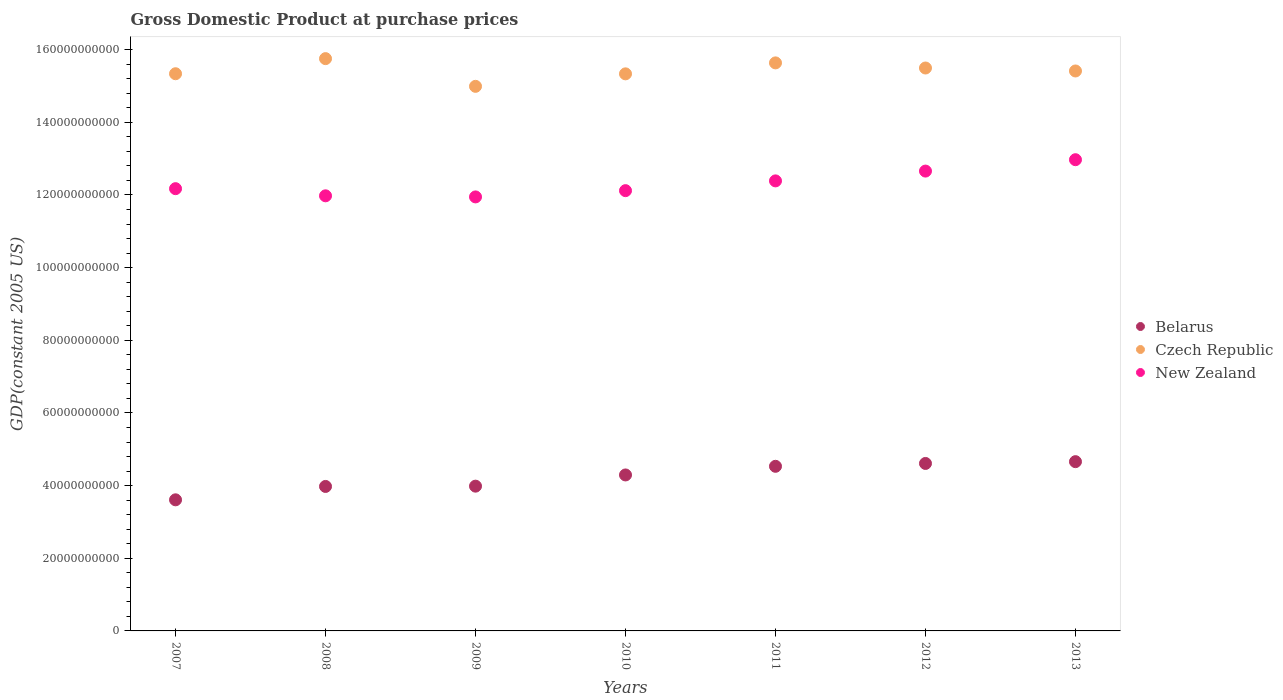Is the number of dotlines equal to the number of legend labels?
Provide a succinct answer. Yes. What is the GDP at purchase prices in Belarus in 2011?
Your answer should be compact. 4.53e+1. Across all years, what is the maximum GDP at purchase prices in Czech Republic?
Give a very brief answer. 1.58e+11. Across all years, what is the minimum GDP at purchase prices in New Zealand?
Your response must be concise. 1.19e+11. In which year was the GDP at purchase prices in Czech Republic maximum?
Give a very brief answer. 2008. What is the total GDP at purchase prices in Belarus in the graph?
Your answer should be very brief. 2.97e+11. What is the difference between the GDP at purchase prices in New Zealand in 2009 and that in 2013?
Offer a very short reply. -1.02e+1. What is the difference between the GDP at purchase prices in New Zealand in 2008 and the GDP at purchase prices in Czech Republic in 2010?
Keep it short and to the point. -3.36e+1. What is the average GDP at purchase prices in New Zealand per year?
Provide a succinct answer. 1.23e+11. In the year 2007, what is the difference between the GDP at purchase prices in Belarus and GDP at purchase prices in New Zealand?
Your answer should be very brief. -8.57e+1. In how many years, is the GDP at purchase prices in New Zealand greater than 128000000000 US$?
Ensure brevity in your answer.  1. What is the ratio of the GDP at purchase prices in Belarus in 2008 to that in 2012?
Keep it short and to the point. 0.86. Is the difference between the GDP at purchase prices in Belarus in 2008 and 2010 greater than the difference between the GDP at purchase prices in New Zealand in 2008 and 2010?
Give a very brief answer. No. What is the difference between the highest and the second highest GDP at purchase prices in Czech Republic?
Give a very brief answer. 1.17e+09. What is the difference between the highest and the lowest GDP at purchase prices in New Zealand?
Keep it short and to the point. 1.02e+1. Is it the case that in every year, the sum of the GDP at purchase prices in Czech Republic and GDP at purchase prices in Belarus  is greater than the GDP at purchase prices in New Zealand?
Provide a short and direct response. Yes. Is the GDP at purchase prices in Czech Republic strictly less than the GDP at purchase prices in New Zealand over the years?
Keep it short and to the point. No. How many years are there in the graph?
Your answer should be very brief. 7. Are the values on the major ticks of Y-axis written in scientific E-notation?
Provide a short and direct response. No. Does the graph contain any zero values?
Offer a very short reply. No. Where does the legend appear in the graph?
Provide a short and direct response. Center right. How are the legend labels stacked?
Make the answer very short. Vertical. What is the title of the graph?
Provide a succinct answer. Gross Domestic Product at purchase prices. Does "Lower middle income" appear as one of the legend labels in the graph?
Offer a very short reply. No. What is the label or title of the X-axis?
Provide a short and direct response. Years. What is the label or title of the Y-axis?
Offer a very short reply. GDP(constant 2005 US). What is the GDP(constant 2005 US) of Belarus in 2007?
Provide a succinct answer. 3.61e+1. What is the GDP(constant 2005 US) in Czech Republic in 2007?
Give a very brief answer. 1.53e+11. What is the GDP(constant 2005 US) in New Zealand in 2007?
Your answer should be very brief. 1.22e+11. What is the GDP(constant 2005 US) in Belarus in 2008?
Make the answer very short. 3.98e+1. What is the GDP(constant 2005 US) in Czech Republic in 2008?
Provide a succinct answer. 1.58e+11. What is the GDP(constant 2005 US) of New Zealand in 2008?
Your answer should be very brief. 1.20e+11. What is the GDP(constant 2005 US) of Belarus in 2009?
Keep it short and to the point. 3.98e+1. What is the GDP(constant 2005 US) of Czech Republic in 2009?
Provide a short and direct response. 1.50e+11. What is the GDP(constant 2005 US) of New Zealand in 2009?
Your answer should be compact. 1.19e+11. What is the GDP(constant 2005 US) in Belarus in 2010?
Give a very brief answer. 4.29e+1. What is the GDP(constant 2005 US) in Czech Republic in 2010?
Your answer should be very brief. 1.53e+11. What is the GDP(constant 2005 US) of New Zealand in 2010?
Provide a succinct answer. 1.21e+11. What is the GDP(constant 2005 US) in Belarus in 2011?
Your answer should be compact. 4.53e+1. What is the GDP(constant 2005 US) in Czech Republic in 2011?
Your answer should be very brief. 1.56e+11. What is the GDP(constant 2005 US) in New Zealand in 2011?
Your response must be concise. 1.24e+11. What is the GDP(constant 2005 US) in Belarus in 2012?
Provide a succinct answer. 4.61e+1. What is the GDP(constant 2005 US) of Czech Republic in 2012?
Provide a succinct answer. 1.55e+11. What is the GDP(constant 2005 US) in New Zealand in 2012?
Your answer should be very brief. 1.27e+11. What is the GDP(constant 2005 US) in Belarus in 2013?
Make the answer very short. 4.66e+1. What is the GDP(constant 2005 US) of Czech Republic in 2013?
Offer a terse response. 1.54e+11. What is the GDP(constant 2005 US) in New Zealand in 2013?
Offer a terse response. 1.30e+11. Across all years, what is the maximum GDP(constant 2005 US) in Belarus?
Provide a short and direct response. 4.66e+1. Across all years, what is the maximum GDP(constant 2005 US) in Czech Republic?
Provide a succinct answer. 1.58e+11. Across all years, what is the maximum GDP(constant 2005 US) of New Zealand?
Your answer should be compact. 1.30e+11. Across all years, what is the minimum GDP(constant 2005 US) in Belarus?
Your answer should be compact. 3.61e+1. Across all years, what is the minimum GDP(constant 2005 US) of Czech Republic?
Give a very brief answer. 1.50e+11. Across all years, what is the minimum GDP(constant 2005 US) of New Zealand?
Give a very brief answer. 1.19e+11. What is the total GDP(constant 2005 US) of Belarus in the graph?
Your answer should be very brief. 2.97e+11. What is the total GDP(constant 2005 US) in Czech Republic in the graph?
Keep it short and to the point. 1.08e+12. What is the total GDP(constant 2005 US) in New Zealand in the graph?
Offer a very short reply. 8.62e+11. What is the difference between the GDP(constant 2005 US) in Belarus in 2007 and that in 2008?
Give a very brief answer. -3.68e+09. What is the difference between the GDP(constant 2005 US) in Czech Republic in 2007 and that in 2008?
Offer a very short reply. -4.16e+09. What is the difference between the GDP(constant 2005 US) in New Zealand in 2007 and that in 2008?
Give a very brief answer. 1.97e+09. What is the difference between the GDP(constant 2005 US) in Belarus in 2007 and that in 2009?
Your answer should be compact. -3.76e+09. What is the difference between the GDP(constant 2005 US) of Czech Republic in 2007 and that in 2009?
Provide a short and direct response. 3.47e+09. What is the difference between the GDP(constant 2005 US) in New Zealand in 2007 and that in 2009?
Your answer should be very brief. 2.27e+09. What is the difference between the GDP(constant 2005 US) of Belarus in 2007 and that in 2010?
Make the answer very short. -6.85e+09. What is the difference between the GDP(constant 2005 US) in Czech Republic in 2007 and that in 2010?
Make the answer very short. 2.90e+07. What is the difference between the GDP(constant 2005 US) in New Zealand in 2007 and that in 2010?
Your answer should be very brief. 5.45e+08. What is the difference between the GDP(constant 2005 US) in Belarus in 2007 and that in 2011?
Provide a short and direct response. -9.23e+09. What is the difference between the GDP(constant 2005 US) in Czech Republic in 2007 and that in 2011?
Your response must be concise. -2.99e+09. What is the difference between the GDP(constant 2005 US) in New Zealand in 2007 and that in 2011?
Offer a very short reply. -2.14e+09. What is the difference between the GDP(constant 2005 US) in Belarus in 2007 and that in 2012?
Offer a terse response. -1.00e+1. What is the difference between the GDP(constant 2005 US) of Czech Republic in 2007 and that in 2012?
Your answer should be very brief. -1.58e+09. What is the difference between the GDP(constant 2005 US) of New Zealand in 2007 and that in 2012?
Provide a succinct answer. -4.84e+09. What is the difference between the GDP(constant 2005 US) in Belarus in 2007 and that in 2013?
Ensure brevity in your answer.  -1.05e+1. What is the difference between the GDP(constant 2005 US) in Czech Republic in 2007 and that in 2013?
Provide a succinct answer. -7.61e+08. What is the difference between the GDP(constant 2005 US) of New Zealand in 2007 and that in 2013?
Your answer should be very brief. -7.97e+09. What is the difference between the GDP(constant 2005 US) of Belarus in 2008 and that in 2009?
Offer a terse response. -7.95e+07. What is the difference between the GDP(constant 2005 US) in Czech Republic in 2008 and that in 2009?
Give a very brief answer. 7.63e+09. What is the difference between the GDP(constant 2005 US) in New Zealand in 2008 and that in 2009?
Ensure brevity in your answer.  3.01e+08. What is the difference between the GDP(constant 2005 US) in Belarus in 2008 and that in 2010?
Keep it short and to the point. -3.16e+09. What is the difference between the GDP(constant 2005 US) in Czech Republic in 2008 and that in 2010?
Provide a short and direct response. 4.19e+09. What is the difference between the GDP(constant 2005 US) of New Zealand in 2008 and that in 2010?
Offer a terse response. -1.42e+09. What is the difference between the GDP(constant 2005 US) of Belarus in 2008 and that in 2011?
Keep it short and to the point. -5.54e+09. What is the difference between the GDP(constant 2005 US) in Czech Republic in 2008 and that in 2011?
Your answer should be compact. 1.17e+09. What is the difference between the GDP(constant 2005 US) in New Zealand in 2008 and that in 2011?
Give a very brief answer. -4.11e+09. What is the difference between the GDP(constant 2005 US) in Belarus in 2008 and that in 2012?
Make the answer very short. -6.33e+09. What is the difference between the GDP(constant 2005 US) of Czech Republic in 2008 and that in 2012?
Your answer should be compact. 2.58e+09. What is the difference between the GDP(constant 2005 US) in New Zealand in 2008 and that in 2012?
Make the answer very short. -6.81e+09. What is the difference between the GDP(constant 2005 US) of Belarus in 2008 and that in 2013?
Your response must be concise. -6.82e+09. What is the difference between the GDP(constant 2005 US) of Czech Republic in 2008 and that in 2013?
Make the answer very short. 3.40e+09. What is the difference between the GDP(constant 2005 US) in New Zealand in 2008 and that in 2013?
Provide a short and direct response. -9.94e+09. What is the difference between the GDP(constant 2005 US) of Belarus in 2009 and that in 2010?
Provide a short and direct response. -3.08e+09. What is the difference between the GDP(constant 2005 US) in Czech Republic in 2009 and that in 2010?
Provide a short and direct response. -3.44e+09. What is the difference between the GDP(constant 2005 US) of New Zealand in 2009 and that in 2010?
Offer a terse response. -1.72e+09. What is the difference between the GDP(constant 2005 US) in Belarus in 2009 and that in 2011?
Keep it short and to the point. -5.46e+09. What is the difference between the GDP(constant 2005 US) in Czech Republic in 2009 and that in 2011?
Offer a very short reply. -6.46e+09. What is the difference between the GDP(constant 2005 US) in New Zealand in 2009 and that in 2011?
Provide a succinct answer. -4.41e+09. What is the difference between the GDP(constant 2005 US) in Belarus in 2009 and that in 2012?
Offer a very short reply. -6.25e+09. What is the difference between the GDP(constant 2005 US) in Czech Republic in 2009 and that in 2012?
Your answer should be compact. -5.05e+09. What is the difference between the GDP(constant 2005 US) in New Zealand in 2009 and that in 2012?
Your answer should be very brief. -7.11e+09. What is the difference between the GDP(constant 2005 US) in Belarus in 2009 and that in 2013?
Your response must be concise. -6.74e+09. What is the difference between the GDP(constant 2005 US) in Czech Republic in 2009 and that in 2013?
Provide a short and direct response. -4.23e+09. What is the difference between the GDP(constant 2005 US) of New Zealand in 2009 and that in 2013?
Provide a short and direct response. -1.02e+1. What is the difference between the GDP(constant 2005 US) of Belarus in 2010 and that in 2011?
Make the answer very short. -2.38e+09. What is the difference between the GDP(constant 2005 US) of Czech Republic in 2010 and that in 2011?
Keep it short and to the point. -3.02e+09. What is the difference between the GDP(constant 2005 US) in New Zealand in 2010 and that in 2011?
Ensure brevity in your answer.  -2.69e+09. What is the difference between the GDP(constant 2005 US) in Belarus in 2010 and that in 2012?
Ensure brevity in your answer.  -3.16e+09. What is the difference between the GDP(constant 2005 US) in Czech Republic in 2010 and that in 2012?
Make the answer very short. -1.61e+09. What is the difference between the GDP(constant 2005 US) in New Zealand in 2010 and that in 2012?
Provide a short and direct response. -5.39e+09. What is the difference between the GDP(constant 2005 US) of Belarus in 2010 and that in 2013?
Your answer should be very brief. -3.66e+09. What is the difference between the GDP(constant 2005 US) in Czech Republic in 2010 and that in 2013?
Make the answer very short. -7.90e+08. What is the difference between the GDP(constant 2005 US) of New Zealand in 2010 and that in 2013?
Provide a short and direct response. -8.52e+09. What is the difference between the GDP(constant 2005 US) in Belarus in 2011 and that in 2012?
Your answer should be very brief. -7.85e+08. What is the difference between the GDP(constant 2005 US) in Czech Republic in 2011 and that in 2012?
Provide a succinct answer. 1.41e+09. What is the difference between the GDP(constant 2005 US) in New Zealand in 2011 and that in 2012?
Keep it short and to the point. -2.70e+09. What is the difference between the GDP(constant 2005 US) of Belarus in 2011 and that in 2013?
Offer a very short reply. -1.28e+09. What is the difference between the GDP(constant 2005 US) of Czech Republic in 2011 and that in 2013?
Ensure brevity in your answer.  2.23e+09. What is the difference between the GDP(constant 2005 US) of New Zealand in 2011 and that in 2013?
Offer a terse response. -5.83e+09. What is the difference between the GDP(constant 2005 US) in Belarus in 2012 and that in 2013?
Offer a terse response. -4.95e+08. What is the difference between the GDP(constant 2005 US) in Czech Republic in 2012 and that in 2013?
Provide a short and direct response. 8.18e+08. What is the difference between the GDP(constant 2005 US) of New Zealand in 2012 and that in 2013?
Give a very brief answer. -3.13e+09. What is the difference between the GDP(constant 2005 US) in Belarus in 2007 and the GDP(constant 2005 US) in Czech Republic in 2008?
Your answer should be very brief. -1.21e+11. What is the difference between the GDP(constant 2005 US) of Belarus in 2007 and the GDP(constant 2005 US) of New Zealand in 2008?
Your answer should be compact. -8.37e+1. What is the difference between the GDP(constant 2005 US) of Czech Republic in 2007 and the GDP(constant 2005 US) of New Zealand in 2008?
Your answer should be compact. 3.36e+1. What is the difference between the GDP(constant 2005 US) in Belarus in 2007 and the GDP(constant 2005 US) in Czech Republic in 2009?
Keep it short and to the point. -1.14e+11. What is the difference between the GDP(constant 2005 US) in Belarus in 2007 and the GDP(constant 2005 US) in New Zealand in 2009?
Ensure brevity in your answer.  -8.34e+1. What is the difference between the GDP(constant 2005 US) in Czech Republic in 2007 and the GDP(constant 2005 US) in New Zealand in 2009?
Offer a very short reply. 3.39e+1. What is the difference between the GDP(constant 2005 US) of Belarus in 2007 and the GDP(constant 2005 US) of Czech Republic in 2010?
Provide a succinct answer. -1.17e+11. What is the difference between the GDP(constant 2005 US) of Belarus in 2007 and the GDP(constant 2005 US) of New Zealand in 2010?
Keep it short and to the point. -8.51e+1. What is the difference between the GDP(constant 2005 US) of Czech Republic in 2007 and the GDP(constant 2005 US) of New Zealand in 2010?
Ensure brevity in your answer.  3.22e+1. What is the difference between the GDP(constant 2005 US) in Belarus in 2007 and the GDP(constant 2005 US) in Czech Republic in 2011?
Make the answer very short. -1.20e+11. What is the difference between the GDP(constant 2005 US) of Belarus in 2007 and the GDP(constant 2005 US) of New Zealand in 2011?
Give a very brief answer. -8.78e+1. What is the difference between the GDP(constant 2005 US) in Czech Republic in 2007 and the GDP(constant 2005 US) in New Zealand in 2011?
Your answer should be compact. 2.95e+1. What is the difference between the GDP(constant 2005 US) of Belarus in 2007 and the GDP(constant 2005 US) of Czech Republic in 2012?
Offer a very short reply. -1.19e+11. What is the difference between the GDP(constant 2005 US) of Belarus in 2007 and the GDP(constant 2005 US) of New Zealand in 2012?
Keep it short and to the point. -9.05e+1. What is the difference between the GDP(constant 2005 US) of Czech Republic in 2007 and the GDP(constant 2005 US) of New Zealand in 2012?
Your answer should be compact. 2.68e+1. What is the difference between the GDP(constant 2005 US) of Belarus in 2007 and the GDP(constant 2005 US) of Czech Republic in 2013?
Ensure brevity in your answer.  -1.18e+11. What is the difference between the GDP(constant 2005 US) in Belarus in 2007 and the GDP(constant 2005 US) in New Zealand in 2013?
Offer a very short reply. -9.36e+1. What is the difference between the GDP(constant 2005 US) in Czech Republic in 2007 and the GDP(constant 2005 US) in New Zealand in 2013?
Provide a succinct answer. 2.37e+1. What is the difference between the GDP(constant 2005 US) of Belarus in 2008 and the GDP(constant 2005 US) of Czech Republic in 2009?
Give a very brief answer. -1.10e+11. What is the difference between the GDP(constant 2005 US) of Belarus in 2008 and the GDP(constant 2005 US) of New Zealand in 2009?
Your answer should be very brief. -7.97e+1. What is the difference between the GDP(constant 2005 US) in Czech Republic in 2008 and the GDP(constant 2005 US) in New Zealand in 2009?
Offer a very short reply. 3.81e+1. What is the difference between the GDP(constant 2005 US) in Belarus in 2008 and the GDP(constant 2005 US) in Czech Republic in 2010?
Your response must be concise. -1.14e+11. What is the difference between the GDP(constant 2005 US) in Belarus in 2008 and the GDP(constant 2005 US) in New Zealand in 2010?
Your response must be concise. -8.14e+1. What is the difference between the GDP(constant 2005 US) in Czech Republic in 2008 and the GDP(constant 2005 US) in New Zealand in 2010?
Your response must be concise. 3.63e+1. What is the difference between the GDP(constant 2005 US) in Belarus in 2008 and the GDP(constant 2005 US) in Czech Republic in 2011?
Give a very brief answer. -1.17e+11. What is the difference between the GDP(constant 2005 US) in Belarus in 2008 and the GDP(constant 2005 US) in New Zealand in 2011?
Give a very brief answer. -8.41e+1. What is the difference between the GDP(constant 2005 US) of Czech Republic in 2008 and the GDP(constant 2005 US) of New Zealand in 2011?
Provide a short and direct response. 3.37e+1. What is the difference between the GDP(constant 2005 US) of Belarus in 2008 and the GDP(constant 2005 US) of Czech Republic in 2012?
Make the answer very short. -1.15e+11. What is the difference between the GDP(constant 2005 US) in Belarus in 2008 and the GDP(constant 2005 US) in New Zealand in 2012?
Give a very brief answer. -8.68e+1. What is the difference between the GDP(constant 2005 US) in Czech Republic in 2008 and the GDP(constant 2005 US) in New Zealand in 2012?
Keep it short and to the point. 3.10e+1. What is the difference between the GDP(constant 2005 US) in Belarus in 2008 and the GDP(constant 2005 US) in Czech Republic in 2013?
Ensure brevity in your answer.  -1.14e+11. What is the difference between the GDP(constant 2005 US) in Belarus in 2008 and the GDP(constant 2005 US) in New Zealand in 2013?
Offer a terse response. -8.99e+1. What is the difference between the GDP(constant 2005 US) in Czech Republic in 2008 and the GDP(constant 2005 US) in New Zealand in 2013?
Provide a short and direct response. 2.78e+1. What is the difference between the GDP(constant 2005 US) of Belarus in 2009 and the GDP(constant 2005 US) of Czech Republic in 2010?
Make the answer very short. -1.13e+11. What is the difference between the GDP(constant 2005 US) in Belarus in 2009 and the GDP(constant 2005 US) in New Zealand in 2010?
Offer a very short reply. -8.13e+1. What is the difference between the GDP(constant 2005 US) of Czech Republic in 2009 and the GDP(constant 2005 US) of New Zealand in 2010?
Ensure brevity in your answer.  2.87e+1. What is the difference between the GDP(constant 2005 US) in Belarus in 2009 and the GDP(constant 2005 US) in Czech Republic in 2011?
Provide a short and direct response. -1.17e+11. What is the difference between the GDP(constant 2005 US) in Belarus in 2009 and the GDP(constant 2005 US) in New Zealand in 2011?
Make the answer very short. -8.40e+1. What is the difference between the GDP(constant 2005 US) in Czech Republic in 2009 and the GDP(constant 2005 US) in New Zealand in 2011?
Provide a short and direct response. 2.60e+1. What is the difference between the GDP(constant 2005 US) in Belarus in 2009 and the GDP(constant 2005 US) in Czech Republic in 2012?
Provide a short and direct response. -1.15e+11. What is the difference between the GDP(constant 2005 US) in Belarus in 2009 and the GDP(constant 2005 US) in New Zealand in 2012?
Your answer should be compact. -8.67e+1. What is the difference between the GDP(constant 2005 US) in Czech Republic in 2009 and the GDP(constant 2005 US) in New Zealand in 2012?
Make the answer very short. 2.33e+1. What is the difference between the GDP(constant 2005 US) of Belarus in 2009 and the GDP(constant 2005 US) of Czech Republic in 2013?
Your answer should be very brief. -1.14e+11. What is the difference between the GDP(constant 2005 US) in Belarus in 2009 and the GDP(constant 2005 US) in New Zealand in 2013?
Your answer should be very brief. -8.99e+1. What is the difference between the GDP(constant 2005 US) in Czech Republic in 2009 and the GDP(constant 2005 US) in New Zealand in 2013?
Provide a succinct answer. 2.02e+1. What is the difference between the GDP(constant 2005 US) in Belarus in 2010 and the GDP(constant 2005 US) in Czech Republic in 2011?
Provide a short and direct response. -1.13e+11. What is the difference between the GDP(constant 2005 US) in Belarus in 2010 and the GDP(constant 2005 US) in New Zealand in 2011?
Make the answer very short. -8.09e+1. What is the difference between the GDP(constant 2005 US) of Czech Republic in 2010 and the GDP(constant 2005 US) of New Zealand in 2011?
Provide a short and direct response. 2.95e+1. What is the difference between the GDP(constant 2005 US) of Belarus in 2010 and the GDP(constant 2005 US) of Czech Republic in 2012?
Provide a succinct answer. -1.12e+11. What is the difference between the GDP(constant 2005 US) in Belarus in 2010 and the GDP(constant 2005 US) in New Zealand in 2012?
Ensure brevity in your answer.  -8.36e+1. What is the difference between the GDP(constant 2005 US) in Czech Republic in 2010 and the GDP(constant 2005 US) in New Zealand in 2012?
Ensure brevity in your answer.  2.68e+1. What is the difference between the GDP(constant 2005 US) of Belarus in 2010 and the GDP(constant 2005 US) of Czech Republic in 2013?
Your answer should be compact. -1.11e+11. What is the difference between the GDP(constant 2005 US) in Belarus in 2010 and the GDP(constant 2005 US) in New Zealand in 2013?
Ensure brevity in your answer.  -8.68e+1. What is the difference between the GDP(constant 2005 US) in Czech Republic in 2010 and the GDP(constant 2005 US) in New Zealand in 2013?
Give a very brief answer. 2.36e+1. What is the difference between the GDP(constant 2005 US) in Belarus in 2011 and the GDP(constant 2005 US) in Czech Republic in 2012?
Provide a succinct answer. -1.10e+11. What is the difference between the GDP(constant 2005 US) in Belarus in 2011 and the GDP(constant 2005 US) in New Zealand in 2012?
Give a very brief answer. -8.13e+1. What is the difference between the GDP(constant 2005 US) of Czech Republic in 2011 and the GDP(constant 2005 US) of New Zealand in 2012?
Your response must be concise. 2.98e+1. What is the difference between the GDP(constant 2005 US) in Belarus in 2011 and the GDP(constant 2005 US) in Czech Republic in 2013?
Provide a succinct answer. -1.09e+11. What is the difference between the GDP(constant 2005 US) in Belarus in 2011 and the GDP(constant 2005 US) in New Zealand in 2013?
Make the answer very short. -8.44e+1. What is the difference between the GDP(constant 2005 US) in Czech Republic in 2011 and the GDP(constant 2005 US) in New Zealand in 2013?
Offer a very short reply. 2.67e+1. What is the difference between the GDP(constant 2005 US) of Belarus in 2012 and the GDP(constant 2005 US) of Czech Republic in 2013?
Provide a succinct answer. -1.08e+11. What is the difference between the GDP(constant 2005 US) in Belarus in 2012 and the GDP(constant 2005 US) in New Zealand in 2013?
Provide a succinct answer. -8.36e+1. What is the difference between the GDP(constant 2005 US) of Czech Republic in 2012 and the GDP(constant 2005 US) of New Zealand in 2013?
Provide a short and direct response. 2.52e+1. What is the average GDP(constant 2005 US) in Belarus per year?
Offer a very short reply. 4.24e+1. What is the average GDP(constant 2005 US) in Czech Republic per year?
Your answer should be very brief. 1.54e+11. What is the average GDP(constant 2005 US) of New Zealand per year?
Make the answer very short. 1.23e+11. In the year 2007, what is the difference between the GDP(constant 2005 US) in Belarus and GDP(constant 2005 US) in Czech Republic?
Your answer should be very brief. -1.17e+11. In the year 2007, what is the difference between the GDP(constant 2005 US) of Belarus and GDP(constant 2005 US) of New Zealand?
Provide a succinct answer. -8.57e+1. In the year 2007, what is the difference between the GDP(constant 2005 US) of Czech Republic and GDP(constant 2005 US) of New Zealand?
Keep it short and to the point. 3.16e+1. In the year 2008, what is the difference between the GDP(constant 2005 US) in Belarus and GDP(constant 2005 US) in Czech Republic?
Offer a very short reply. -1.18e+11. In the year 2008, what is the difference between the GDP(constant 2005 US) in Belarus and GDP(constant 2005 US) in New Zealand?
Ensure brevity in your answer.  -8.00e+1. In the year 2008, what is the difference between the GDP(constant 2005 US) in Czech Republic and GDP(constant 2005 US) in New Zealand?
Offer a very short reply. 3.78e+1. In the year 2009, what is the difference between the GDP(constant 2005 US) in Belarus and GDP(constant 2005 US) in Czech Republic?
Make the answer very short. -1.10e+11. In the year 2009, what is the difference between the GDP(constant 2005 US) in Belarus and GDP(constant 2005 US) in New Zealand?
Offer a terse response. -7.96e+1. In the year 2009, what is the difference between the GDP(constant 2005 US) of Czech Republic and GDP(constant 2005 US) of New Zealand?
Your answer should be very brief. 3.04e+1. In the year 2010, what is the difference between the GDP(constant 2005 US) of Belarus and GDP(constant 2005 US) of Czech Republic?
Ensure brevity in your answer.  -1.10e+11. In the year 2010, what is the difference between the GDP(constant 2005 US) in Belarus and GDP(constant 2005 US) in New Zealand?
Offer a terse response. -7.83e+1. In the year 2010, what is the difference between the GDP(constant 2005 US) of Czech Republic and GDP(constant 2005 US) of New Zealand?
Provide a succinct answer. 3.22e+1. In the year 2011, what is the difference between the GDP(constant 2005 US) of Belarus and GDP(constant 2005 US) of Czech Republic?
Keep it short and to the point. -1.11e+11. In the year 2011, what is the difference between the GDP(constant 2005 US) in Belarus and GDP(constant 2005 US) in New Zealand?
Ensure brevity in your answer.  -7.86e+1. In the year 2011, what is the difference between the GDP(constant 2005 US) of Czech Republic and GDP(constant 2005 US) of New Zealand?
Offer a terse response. 3.25e+1. In the year 2012, what is the difference between the GDP(constant 2005 US) of Belarus and GDP(constant 2005 US) of Czech Republic?
Offer a very short reply. -1.09e+11. In the year 2012, what is the difference between the GDP(constant 2005 US) in Belarus and GDP(constant 2005 US) in New Zealand?
Offer a very short reply. -8.05e+1. In the year 2012, what is the difference between the GDP(constant 2005 US) in Czech Republic and GDP(constant 2005 US) in New Zealand?
Make the answer very short. 2.84e+1. In the year 2013, what is the difference between the GDP(constant 2005 US) of Belarus and GDP(constant 2005 US) of Czech Republic?
Keep it short and to the point. -1.08e+11. In the year 2013, what is the difference between the GDP(constant 2005 US) in Belarus and GDP(constant 2005 US) in New Zealand?
Provide a short and direct response. -8.31e+1. In the year 2013, what is the difference between the GDP(constant 2005 US) of Czech Republic and GDP(constant 2005 US) of New Zealand?
Ensure brevity in your answer.  2.44e+1. What is the ratio of the GDP(constant 2005 US) of Belarus in 2007 to that in 2008?
Make the answer very short. 0.91. What is the ratio of the GDP(constant 2005 US) of Czech Republic in 2007 to that in 2008?
Make the answer very short. 0.97. What is the ratio of the GDP(constant 2005 US) in New Zealand in 2007 to that in 2008?
Your answer should be compact. 1.02. What is the ratio of the GDP(constant 2005 US) of Belarus in 2007 to that in 2009?
Your answer should be very brief. 0.91. What is the ratio of the GDP(constant 2005 US) of Czech Republic in 2007 to that in 2009?
Your answer should be compact. 1.02. What is the ratio of the GDP(constant 2005 US) in New Zealand in 2007 to that in 2009?
Your answer should be very brief. 1.02. What is the ratio of the GDP(constant 2005 US) in Belarus in 2007 to that in 2010?
Offer a terse response. 0.84. What is the ratio of the GDP(constant 2005 US) in Czech Republic in 2007 to that in 2010?
Ensure brevity in your answer.  1. What is the ratio of the GDP(constant 2005 US) in New Zealand in 2007 to that in 2010?
Your answer should be very brief. 1. What is the ratio of the GDP(constant 2005 US) in Belarus in 2007 to that in 2011?
Ensure brevity in your answer.  0.8. What is the ratio of the GDP(constant 2005 US) in Czech Republic in 2007 to that in 2011?
Provide a short and direct response. 0.98. What is the ratio of the GDP(constant 2005 US) of New Zealand in 2007 to that in 2011?
Ensure brevity in your answer.  0.98. What is the ratio of the GDP(constant 2005 US) in Belarus in 2007 to that in 2012?
Keep it short and to the point. 0.78. What is the ratio of the GDP(constant 2005 US) in Czech Republic in 2007 to that in 2012?
Your response must be concise. 0.99. What is the ratio of the GDP(constant 2005 US) of New Zealand in 2007 to that in 2012?
Your answer should be compact. 0.96. What is the ratio of the GDP(constant 2005 US) in Belarus in 2007 to that in 2013?
Provide a short and direct response. 0.77. What is the ratio of the GDP(constant 2005 US) in New Zealand in 2007 to that in 2013?
Provide a short and direct response. 0.94. What is the ratio of the GDP(constant 2005 US) in Belarus in 2008 to that in 2009?
Give a very brief answer. 1. What is the ratio of the GDP(constant 2005 US) in Czech Republic in 2008 to that in 2009?
Offer a very short reply. 1.05. What is the ratio of the GDP(constant 2005 US) in Belarus in 2008 to that in 2010?
Your response must be concise. 0.93. What is the ratio of the GDP(constant 2005 US) in Czech Republic in 2008 to that in 2010?
Provide a short and direct response. 1.03. What is the ratio of the GDP(constant 2005 US) of New Zealand in 2008 to that in 2010?
Keep it short and to the point. 0.99. What is the ratio of the GDP(constant 2005 US) in Belarus in 2008 to that in 2011?
Offer a very short reply. 0.88. What is the ratio of the GDP(constant 2005 US) of Czech Republic in 2008 to that in 2011?
Your response must be concise. 1.01. What is the ratio of the GDP(constant 2005 US) of New Zealand in 2008 to that in 2011?
Provide a short and direct response. 0.97. What is the ratio of the GDP(constant 2005 US) in Belarus in 2008 to that in 2012?
Make the answer very short. 0.86. What is the ratio of the GDP(constant 2005 US) in Czech Republic in 2008 to that in 2012?
Keep it short and to the point. 1.02. What is the ratio of the GDP(constant 2005 US) in New Zealand in 2008 to that in 2012?
Offer a terse response. 0.95. What is the ratio of the GDP(constant 2005 US) in Belarus in 2008 to that in 2013?
Ensure brevity in your answer.  0.85. What is the ratio of the GDP(constant 2005 US) of Czech Republic in 2008 to that in 2013?
Keep it short and to the point. 1.02. What is the ratio of the GDP(constant 2005 US) in New Zealand in 2008 to that in 2013?
Ensure brevity in your answer.  0.92. What is the ratio of the GDP(constant 2005 US) of Belarus in 2009 to that in 2010?
Ensure brevity in your answer.  0.93. What is the ratio of the GDP(constant 2005 US) of Czech Republic in 2009 to that in 2010?
Offer a terse response. 0.98. What is the ratio of the GDP(constant 2005 US) in New Zealand in 2009 to that in 2010?
Keep it short and to the point. 0.99. What is the ratio of the GDP(constant 2005 US) of Belarus in 2009 to that in 2011?
Provide a short and direct response. 0.88. What is the ratio of the GDP(constant 2005 US) of Czech Republic in 2009 to that in 2011?
Make the answer very short. 0.96. What is the ratio of the GDP(constant 2005 US) of New Zealand in 2009 to that in 2011?
Provide a succinct answer. 0.96. What is the ratio of the GDP(constant 2005 US) in Belarus in 2009 to that in 2012?
Provide a short and direct response. 0.86. What is the ratio of the GDP(constant 2005 US) of Czech Republic in 2009 to that in 2012?
Keep it short and to the point. 0.97. What is the ratio of the GDP(constant 2005 US) in New Zealand in 2009 to that in 2012?
Ensure brevity in your answer.  0.94. What is the ratio of the GDP(constant 2005 US) in Belarus in 2009 to that in 2013?
Offer a very short reply. 0.86. What is the ratio of the GDP(constant 2005 US) in Czech Republic in 2009 to that in 2013?
Provide a short and direct response. 0.97. What is the ratio of the GDP(constant 2005 US) in New Zealand in 2009 to that in 2013?
Your answer should be very brief. 0.92. What is the ratio of the GDP(constant 2005 US) in Belarus in 2010 to that in 2011?
Give a very brief answer. 0.95. What is the ratio of the GDP(constant 2005 US) of Czech Republic in 2010 to that in 2011?
Provide a short and direct response. 0.98. What is the ratio of the GDP(constant 2005 US) in New Zealand in 2010 to that in 2011?
Keep it short and to the point. 0.98. What is the ratio of the GDP(constant 2005 US) in Belarus in 2010 to that in 2012?
Ensure brevity in your answer.  0.93. What is the ratio of the GDP(constant 2005 US) in New Zealand in 2010 to that in 2012?
Provide a short and direct response. 0.96. What is the ratio of the GDP(constant 2005 US) in Belarus in 2010 to that in 2013?
Your answer should be very brief. 0.92. What is the ratio of the GDP(constant 2005 US) of Czech Republic in 2010 to that in 2013?
Provide a short and direct response. 0.99. What is the ratio of the GDP(constant 2005 US) in New Zealand in 2010 to that in 2013?
Offer a terse response. 0.93. What is the ratio of the GDP(constant 2005 US) of Czech Republic in 2011 to that in 2012?
Keep it short and to the point. 1.01. What is the ratio of the GDP(constant 2005 US) of New Zealand in 2011 to that in 2012?
Give a very brief answer. 0.98. What is the ratio of the GDP(constant 2005 US) in Belarus in 2011 to that in 2013?
Your answer should be compact. 0.97. What is the ratio of the GDP(constant 2005 US) in Czech Republic in 2011 to that in 2013?
Your answer should be compact. 1.01. What is the ratio of the GDP(constant 2005 US) in New Zealand in 2011 to that in 2013?
Offer a very short reply. 0.95. What is the ratio of the GDP(constant 2005 US) of Belarus in 2012 to that in 2013?
Provide a succinct answer. 0.99. What is the ratio of the GDP(constant 2005 US) in Czech Republic in 2012 to that in 2013?
Give a very brief answer. 1.01. What is the ratio of the GDP(constant 2005 US) in New Zealand in 2012 to that in 2013?
Offer a very short reply. 0.98. What is the difference between the highest and the second highest GDP(constant 2005 US) of Belarus?
Your response must be concise. 4.95e+08. What is the difference between the highest and the second highest GDP(constant 2005 US) of Czech Republic?
Provide a succinct answer. 1.17e+09. What is the difference between the highest and the second highest GDP(constant 2005 US) in New Zealand?
Your answer should be very brief. 3.13e+09. What is the difference between the highest and the lowest GDP(constant 2005 US) of Belarus?
Your answer should be compact. 1.05e+1. What is the difference between the highest and the lowest GDP(constant 2005 US) in Czech Republic?
Make the answer very short. 7.63e+09. What is the difference between the highest and the lowest GDP(constant 2005 US) of New Zealand?
Give a very brief answer. 1.02e+1. 